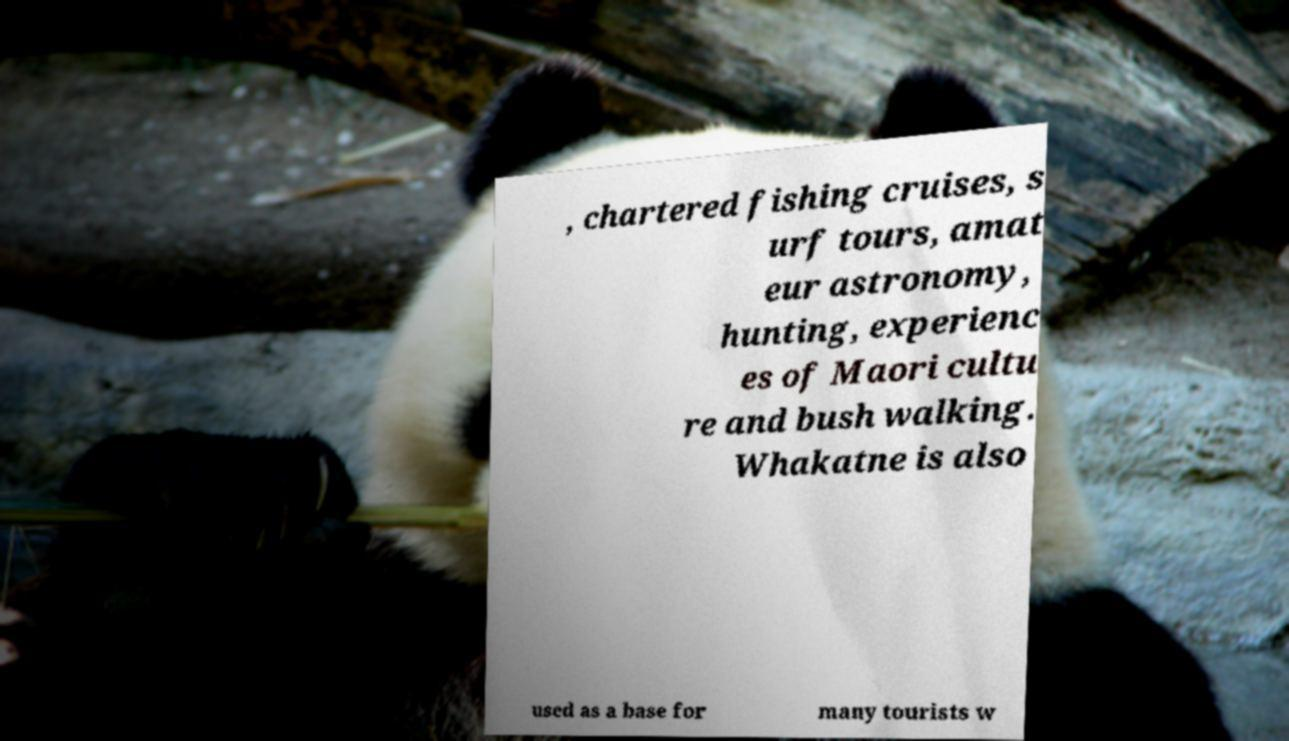I need the written content from this picture converted into text. Can you do that? , chartered fishing cruises, s urf tours, amat eur astronomy, hunting, experienc es of Maori cultu re and bush walking. Whakatne is also used as a base for many tourists w 